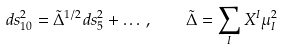<formula> <loc_0><loc_0><loc_500><loc_500>d s _ { 1 0 } ^ { 2 } = \tilde { \Delta } ^ { 1 / 2 } d s _ { 5 } ^ { 2 } + \dots \, , \quad \tilde { \Delta } = \sum _ { I } X ^ { I } \mu _ { I } ^ { 2 }</formula> 